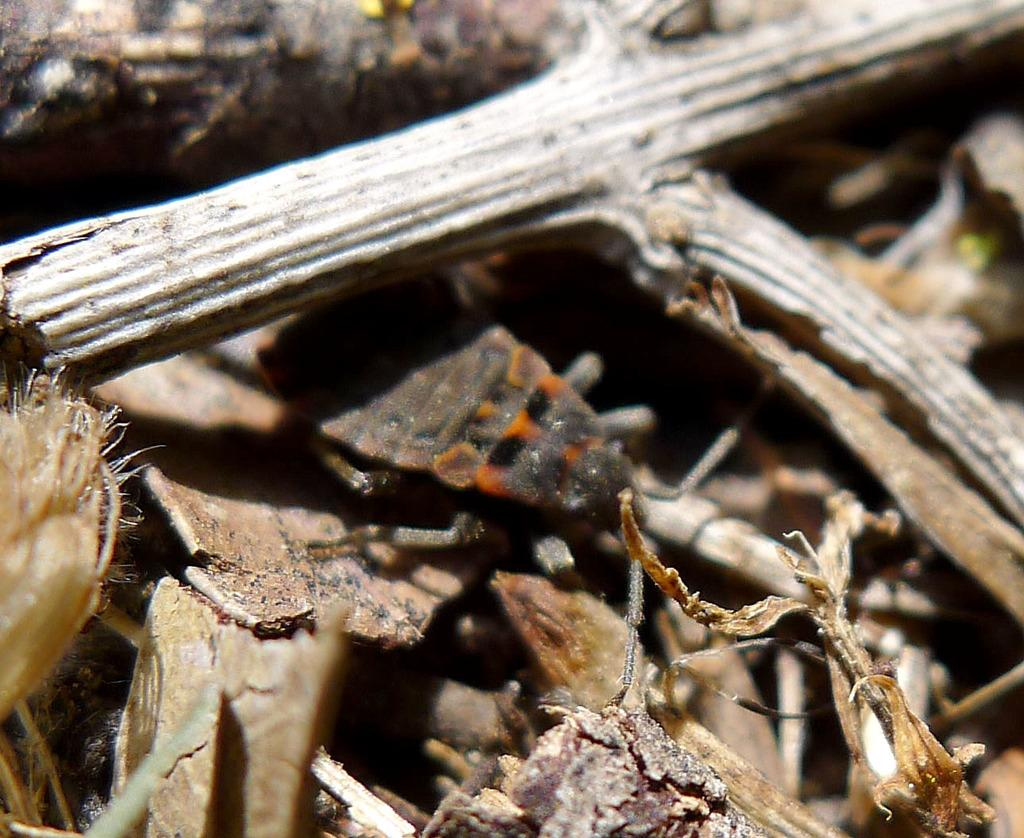What type of creature is present in the image? There is an insect in the image. What material are the sticks made of in the image? The sticks in the image are made of wood. Can you describe the unspecified objects in the image? Unfortunately, the facts provided do not specify the nature or characteristics of the unspecified objects in the image. What type of interest does the insect have in the toes of the minister in the image? There is no minister or toes present in the image, and therefore no such interaction can be observed. 